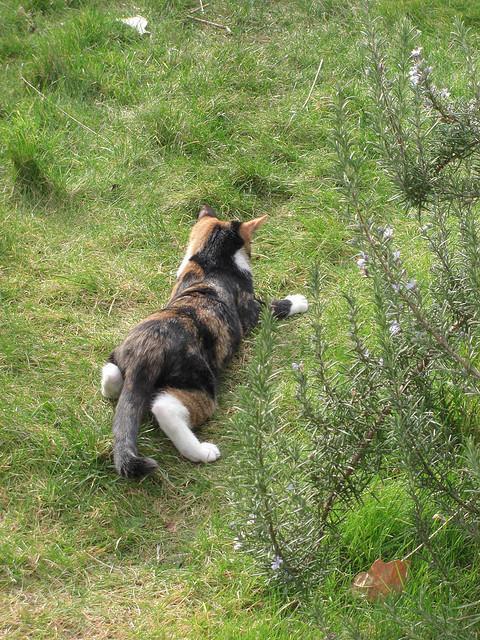How many people wears the blue jersey?
Give a very brief answer. 0. 